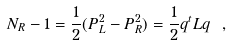<formula> <loc_0><loc_0><loc_500><loc_500>N _ { R } - 1 = \frac { 1 } { 2 } ( P _ { L } ^ { 2 } - P _ { R } ^ { 2 } ) = \frac { 1 } { 2 } q ^ { t } L q \ ,</formula> 